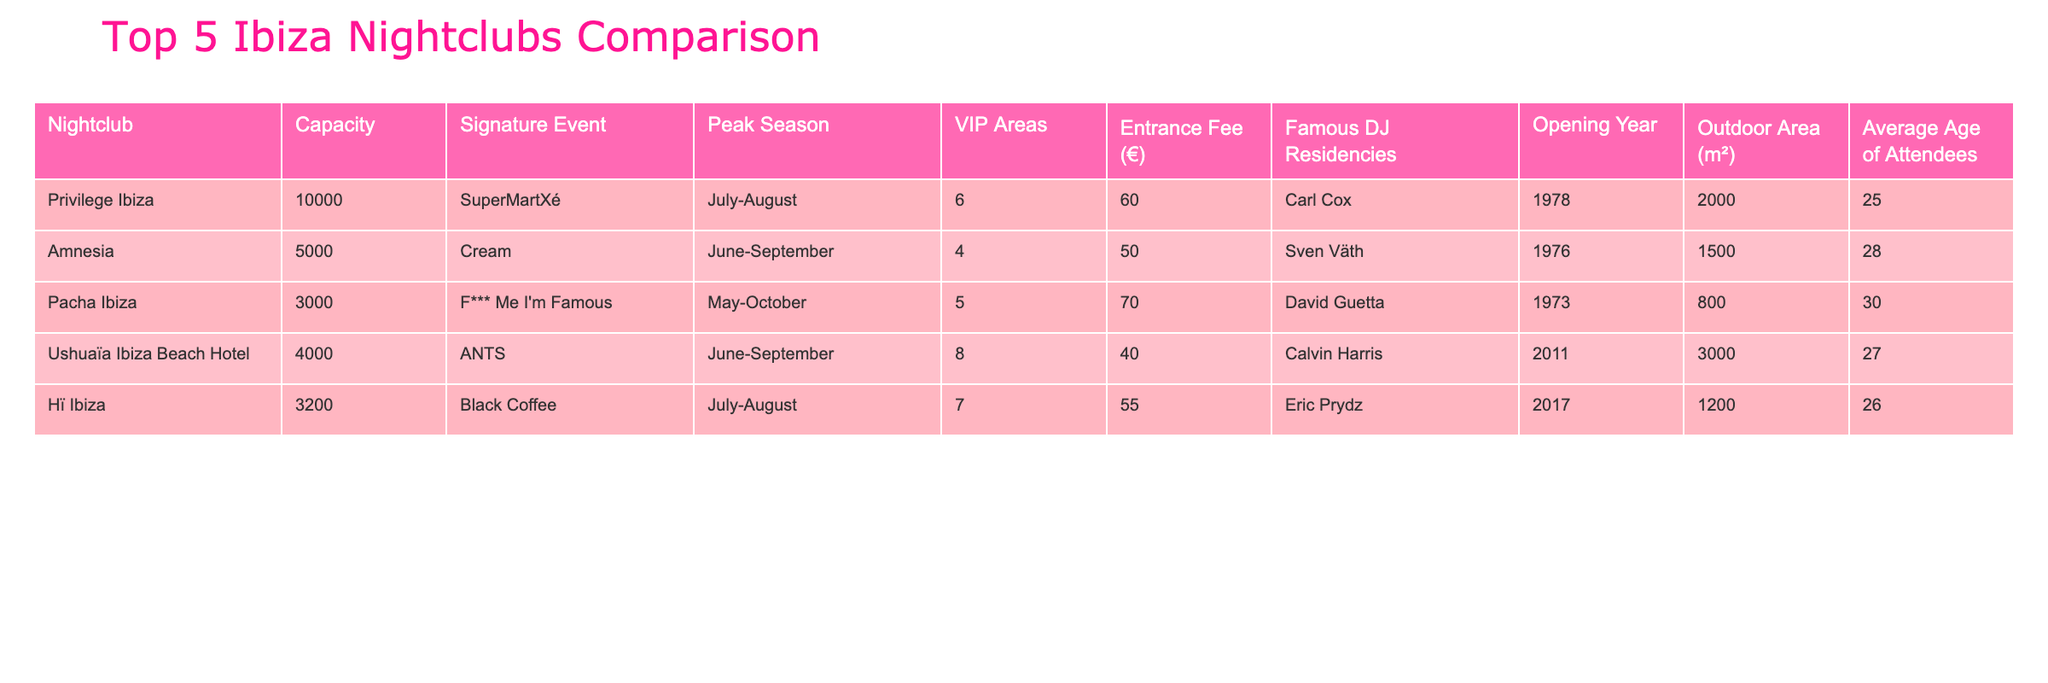What is the capacity of Privilege Ibiza? The table lists the capacity of each nightclub. Looking at Privilege Ibiza's row, the capacity shown is 10,000.
Answer: 10,000 Which nightclub has the highest entrance fee? The entrance fees for each nightclub are listed in the Entrance Fee column. Comparing the values, the highest fee is €70 for Pacha Ibiza.
Answer: €70 How many VIP areas does Ushuaïa Ibiza Beach Hotel have? The number of VIP areas for each nightclub is provided in the VIP Areas column. For Ushuaïa Ibiza Beach Hotel, it shows 8 VIP areas.
Answer: 8 What is the average capacity of the top 5 Ibiza nightclubs? The capacities of the nightclubs are: 10,000, 5,000, 3,000, 4,000, and 3,200. First, add them up: 10,000 + 5,000 + 3,000 + 4,000 + 3,200 = 25,200, then divide by 5: 25,200 / 5 = 5,040.
Answer: 5,040 Is Amnesia's signature event during the peak season? The signature event for Amnesia is Cream, and the peak season is listed as June-September. Since this overlaps with the peak, the answer is yes.
Answer: Yes How many famous DJ residencies does Pacha Ibiza have compared to Hï Ibiza? Pacha Ibiza has David Guetta as a residency, and Hï Ibiza has Eric Prydz. Since each has one residency, they are equal.
Answer: Equal Which nightclub was opened first? The opening years of the nightclubs indicate Privilege Ibiza opened in 1978, Amnesia in 1976, Pacha Ibiza in 1973, Ushuaïa Ibiza Beach Hotel in 2011, and Hï Ibiza in 2017. The earliest is Pacha Ibiza in 1973.
Answer: Pacha Ibiza What is the average age of attendees at the nightclubs listed? The average ages provided in the table are 25, 28, 30, 27, and 26. First, sum these numbers: 25 + 28 + 30 + 27 + 26 = 136, then divide by 5: 136 / 5 = 27.2.
Answer: 27.2 